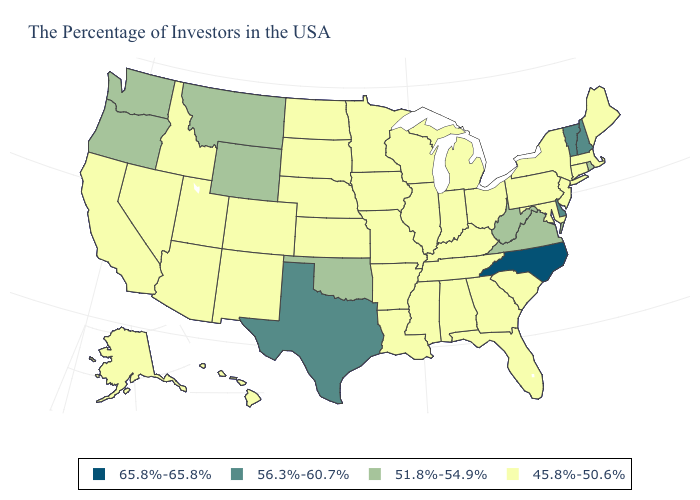Name the states that have a value in the range 51.8%-54.9%?
Keep it brief. Rhode Island, Virginia, West Virginia, Oklahoma, Wyoming, Montana, Washington, Oregon. Does the map have missing data?
Be succinct. No. What is the highest value in the USA?
Be succinct. 65.8%-65.8%. Which states have the lowest value in the USA?
Give a very brief answer. Maine, Massachusetts, Connecticut, New York, New Jersey, Maryland, Pennsylvania, South Carolina, Ohio, Florida, Georgia, Michigan, Kentucky, Indiana, Alabama, Tennessee, Wisconsin, Illinois, Mississippi, Louisiana, Missouri, Arkansas, Minnesota, Iowa, Kansas, Nebraska, South Dakota, North Dakota, Colorado, New Mexico, Utah, Arizona, Idaho, Nevada, California, Alaska, Hawaii. Does Oregon have the lowest value in the USA?
Write a very short answer. No. Does Washington have the lowest value in the West?
Answer briefly. No. Among the states that border Oklahoma , which have the highest value?
Be succinct. Texas. What is the lowest value in the USA?
Give a very brief answer. 45.8%-50.6%. Name the states that have a value in the range 65.8%-65.8%?
Concise answer only. North Carolina. What is the value of Georgia?
Keep it brief. 45.8%-50.6%. Does New Jersey have the highest value in the USA?
Keep it brief. No. What is the lowest value in the West?
Answer briefly. 45.8%-50.6%. Which states have the lowest value in the MidWest?
Concise answer only. Ohio, Michigan, Indiana, Wisconsin, Illinois, Missouri, Minnesota, Iowa, Kansas, Nebraska, South Dakota, North Dakota. Name the states that have a value in the range 65.8%-65.8%?
Be succinct. North Carolina. Name the states that have a value in the range 56.3%-60.7%?
Give a very brief answer. New Hampshire, Vermont, Delaware, Texas. 